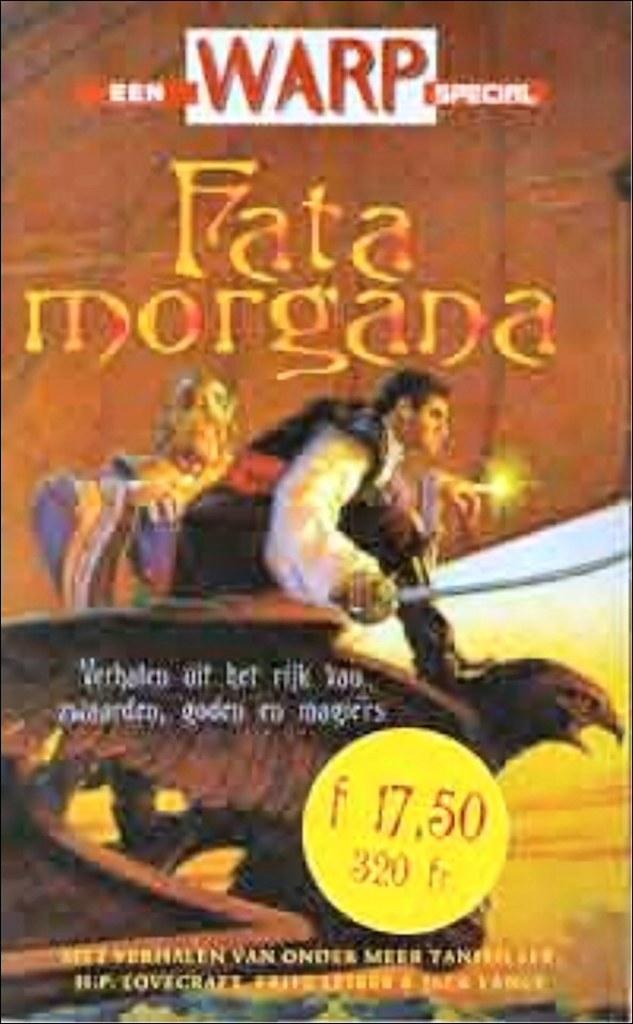How would you summarize this image in a sentence or two? In this image we can see the advertisement. 